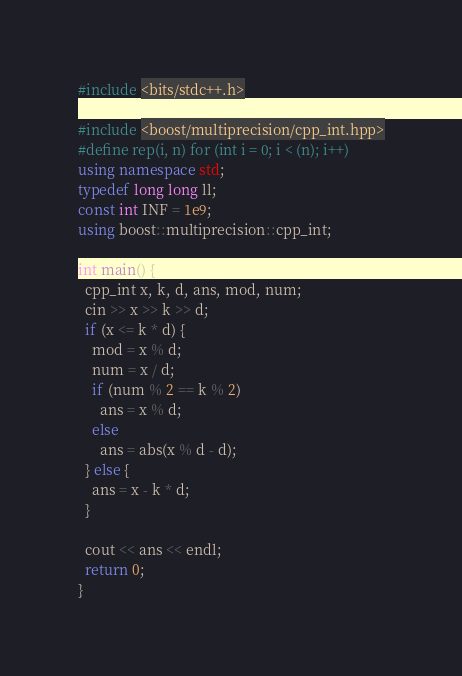<code> <loc_0><loc_0><loc_500><loc_500><_C++_>#include <bits/stdc++.h>

#include <boost/multiprecision/cpp_int.hpp>
#define rep(i, n) for (int i = 0; i < (n); i++)
using namespace std;
typedef long long ll;
const int INF = 1e9;
using boost::multiprecision::cpp_int;

int main() {
  cpp_int x, k, d, ans, mod, num;
  cin >> x >> k >> d;
  if (x <= k * d) {
    mod = x % d;
    num = x / d;
    if (num % 2 == k % 2)
      ans = x % d;
    else
      ans = abs(x % d - d);
  } else {
    ans = x - k * d;
  }

  cout << ans << endl;
  return 0;
}</code> 